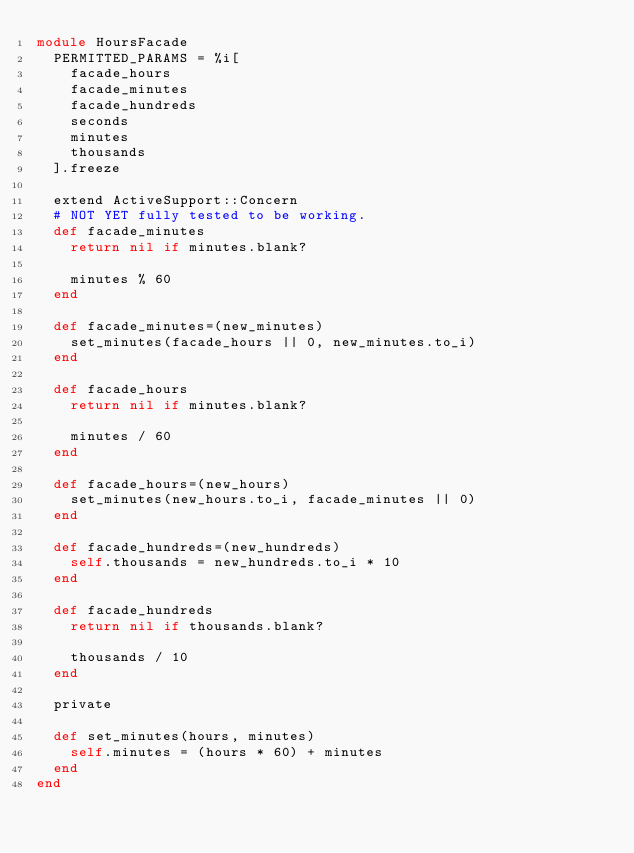<code> <loc_0><loc_0><loc_500><loc_500><_Ruby_>module HoursFacade
  PERMITTED_PARAMS = %i[
    facade_hours
    facade_minutes
    facade_hundreds
    seconds
    minutes
    thousands
  ].freeze

  extend ActiveSupport::Concern
  # NOT YET fully tested to be working.
  def facade_minutes
    return nil if minutes.blank?

    minutes % 60
  end

  def facade_minutes=(new_minutes)
    set_minutes(facade_hours || 0, new_minutes.to_i)
  end

  def facade_hours
    return nil if minutes.blank?

    minutes / 60
  end

  def facade_hours=(new_hours)
    set_minutes(new_hours.to_i, facade_minutes || 0)
  end

  def facade_hundreds=(new_hundreds)
    self.thousands = new_hundreds.to_i * 10
  end

  def facade_hundreds
    return nil if thousands.blank?

    thousands / 10
  end

  private

  def set_minutes(hours, minutes)
    self.minutes = (hours * 60) + minutes
  end
end
</code> 